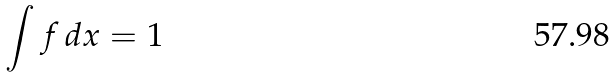Convert formula to latex. <formula><loc_0><loc_0><loc_500><loc_500>\int f \, d x = 1</formula> 